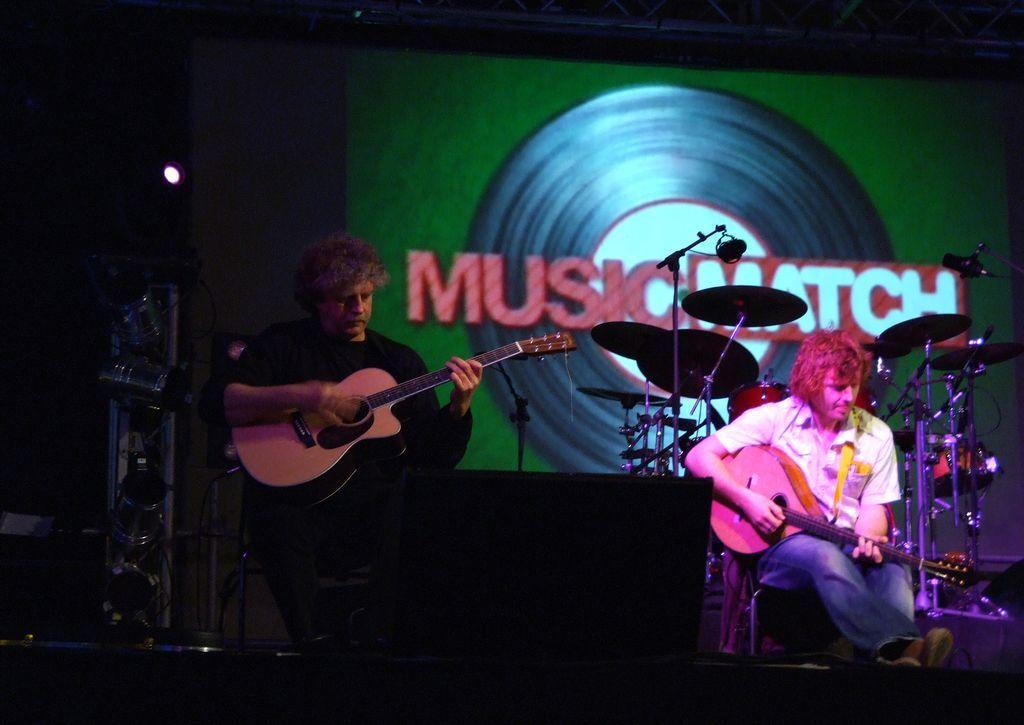How many people are in the image? There are two people in the image. What are the people doing in the image? The people are sitting and playing musical instruments. What can be seen in the background of the image? There is a screen and drums in the background of the image. What is located at the front of the image? There is a speaker at the front of the image. How many screws can be seen holding the division together in the image? There are no screws or divisions present in the image. Can you see a cow in the image? There is no cow present in the image. 